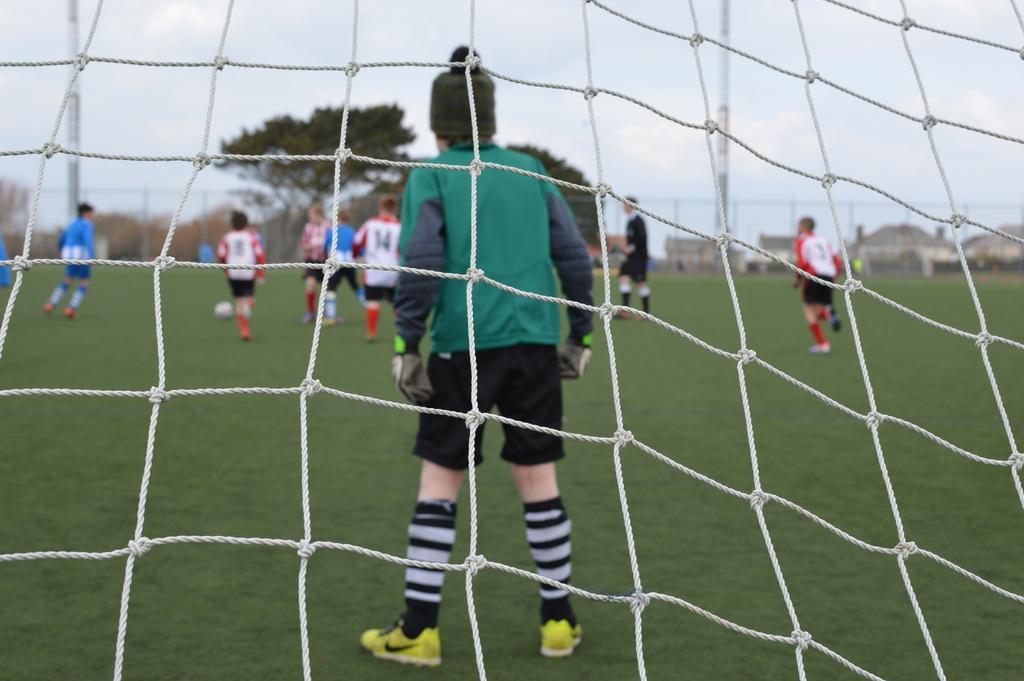What number is on the middle player with the white jersey?
Your response must be concise. 14. The number on the far right players is?
Your response must be concise. 3. 